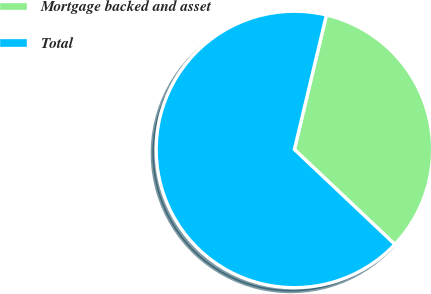Convert chart. <chart><loc_0><loc_0><loc_500><loc_500><pie_chart><fcel>Mortgage backed and asset<fcel>Total<nl><fcel>33.33%<fcel>66.67%<nl></chart> 